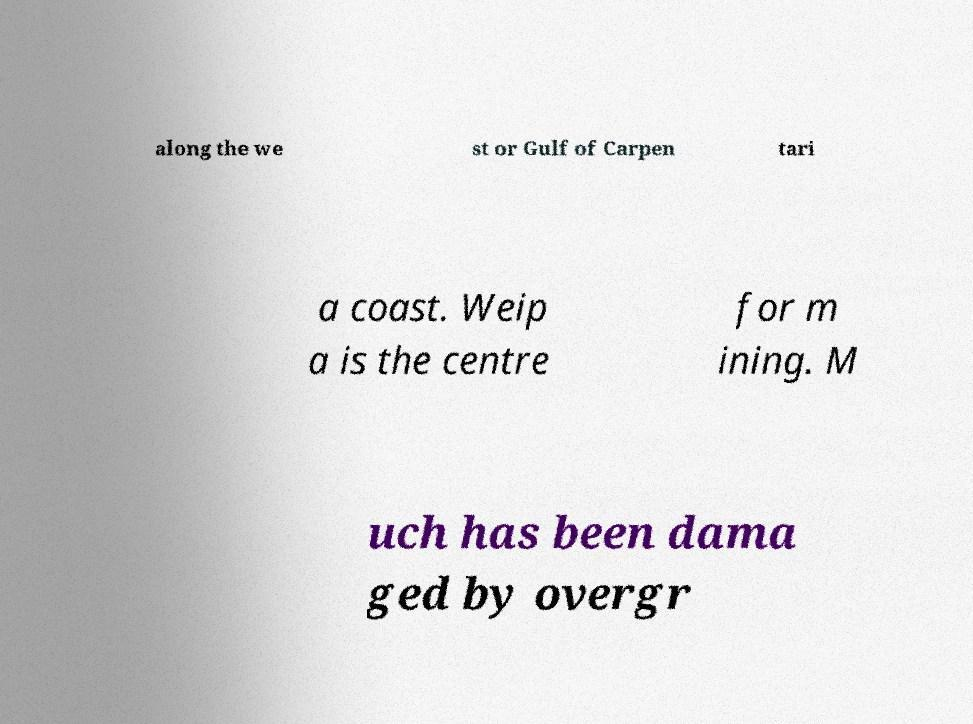For documentation purposes, I need the text within this image transcribed. Could you provide that? along the we st or Gulf of Carpen tari a coast. Weip a is the centre for m ining. M uch has been dama ged by overgr 